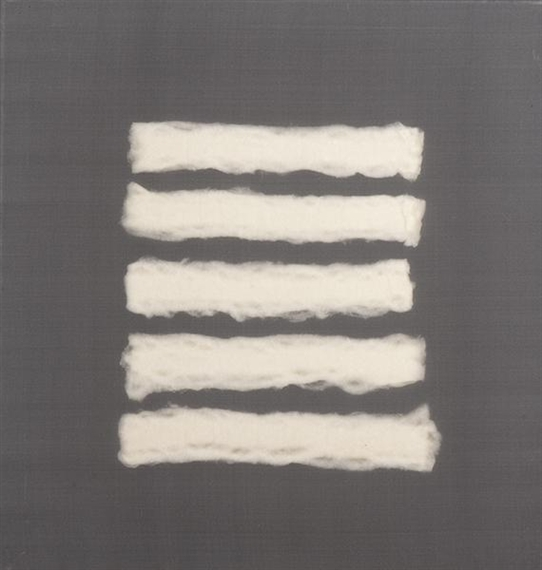This artwork now exists in a future where AI creates art. How would that affect its interpretation? In a future where AI plays a significant role in creating art, this piece could be viewed as a collaboration between human creativity and machine precision. The white strips might be seen as digitally generated patterns executed with such precision that they evoke a sense of artificial perfection. The uneven texture, however, suggests a deliberate choice to retain an element of organic imperfection, perhaps as a homage to traditional, hand-crafted art. This interplay between the human touch and AI assistance could give the artwork a dual-layered interpretation: one that respects the human connection to art and another that celebrates technological advancements. Furthermore, such AI-influenced art would provoke discussions about the nature of creativity, originality, and the future direction of artistic expression. 